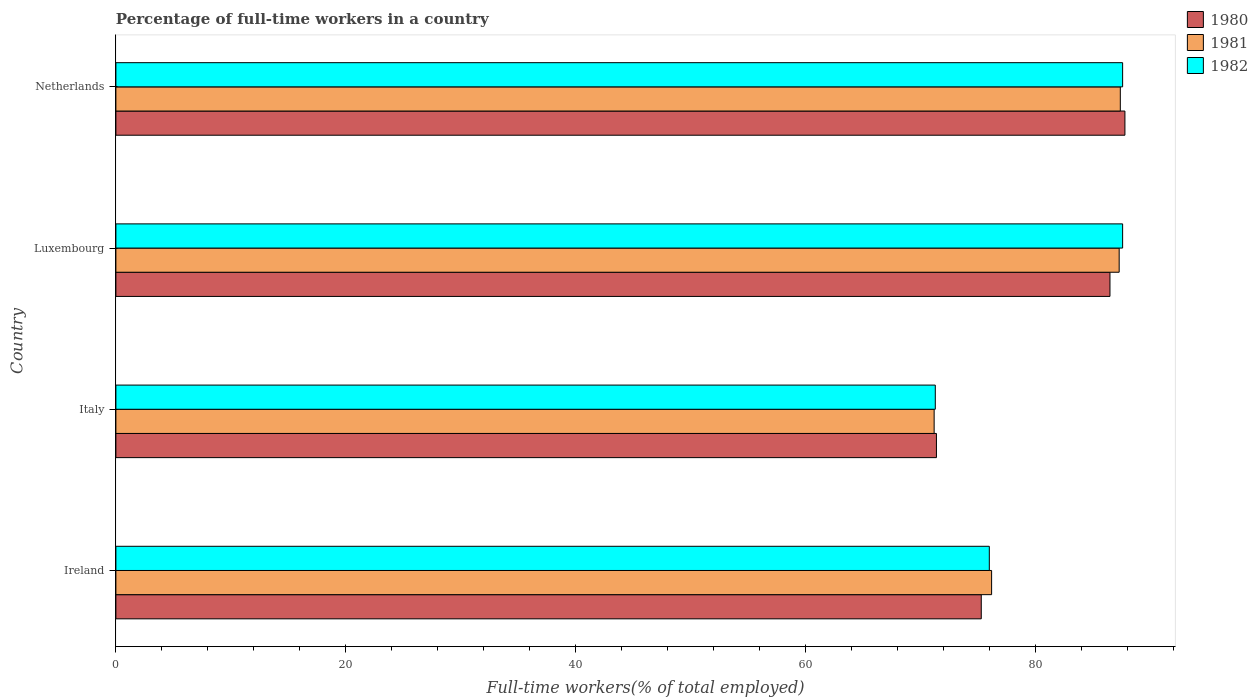How many groups of bars are there?
Provide a short and direct response. 4. Are the number of bars per tick equal to the number of legend labels?
Provide a short and direct response. Yes. What is the label of the 2nd group of bars from the top?
Keep it short and to the point. Luxembourg. What is the percentage of full-time workers in 1980 in Italy?
Give a very brief answer. 71.4. Across all countries, what is the maximum percentage of full-time workers in 1982?
Your answer should be compact. 87.6. Across all countries, what is the minimum percentage of full-time workers in 1981?
Offer a terse response. 71.2. In which country was the percentage of full-time workers in 1982 maximum?
Offer a terse response. Luxembourg. In which country was the percentage of full-time workers in 1981 minimum?
Keep it short and to the point. Italy. What is the total percentage of full-time workers in 1982 in the graph?
Your answer should be very brief. 322.5. What is the difference between the percentage of full-time workers in 1981 in Ireland and that in Luxembourg?
Provide a short and direct response. -11.1. What is the difference between the percentage of full-time workers in 1982 in Italy and the percentage of full-time workers in 1980 in Netherlands?
Keep it short and to the point. -16.5. What is the average percentage of full-time workers in 1981 per country?
Provide a succinct answer. 80.52. What is the difference between the percentage of full-time workers in 1980 and percentage of full-time workers in 1982 in Ireland?
Your answer should be compact. -0.7. In how many countries, is the percentage of full-time workers in 1982 greater than 44 %?
Give a very brief answer. 4. What is the ratio of the percentage of full-time workers in 1981 in Luxembourg to that in Netherlands?
Make the answer very short. 1. Is the difference between the percentage of full-time workers in 1980 in Ireland and Netherlands greater than the difference between the percentage of full-time workers in 1982 in Ireland and Netherlands?
Make the answer very short. No. What is the difference between the highest and the second highest percentage of full-time workers in 1981?
Provide a short and direct response. 0.1. What is the difference between the highest and the lowest percentage of full-time workers in 1981?
Provide a succinct answer. 16.2. In how many countries, is the percentage of full-time workers in 1982 greater than the average percentage of full-time workers in 1982 taken over all countries?
Your response must be concise. 2. Is the sum of the percentage of full-time workers in 1981 in Ireland and Italy greater than the maximum percentage of full-time workers in 1982 across all countries?
Make the answer very short. Yes. What does the 3rd bar from the top in Ireland represents?
Provide a short and direct response. 1980. What does the 3rd bar from the bottom in Luxembourg represents?
Offer a terse response. 1982. How many bars are there?
Your answer should be very brief. 12. Are all the bars in the graph horizontal?
Make the answer very short. Yes. How many countries are there in the graph?
Your answer should be compact. 4. What is the difference between two consecutive major ticks on the X-axis?
Your answer should be very brief. 20. Are the values on the major ticks of X-axis written in scientific E-notation?
Keep it short and to the point. No. Does the graph contain any zero values?
Give a very brief answer. No. What is the title of the graph?
Offer a very short reply. Percentage of full-time workers in a country. What is the label or title of the X-axis?
Make the answer very short. Full-time workers(% of total employed). What is the Full-time workers(% of total employed) in 1980 in Ireland?
Your answer should be compact. 75.3. What is the Full-time workers(% of total employed) in 1981 in Ireland?
Keep it short and to the point. 76.2. What is the Full-time workers(% of total employed) in 1980 in Italy?
Keep it short and to the point. 71.4. What is the Full-time workers(% of total employed) in 1981 in Italy?
Provide a short and direct response. 71.2. What is the Full-time workers(% of total employed) of 1982 in Italy?
Provide a succinct answer. 71.3. What is the Full-time workers(% of total employed) of 1980 in Luxembourg?
Ensure brevity in your answer.  86.5. What is the Full-time workers(% of total employed) in 1981 in Luxembourg?
Your answer should be very brief. 87.3. What is the Full-time workers(% of total employed) in 1982 in Luxembourg?
Make the answer very short. 87.6. What is the Full-time workers(% of total employed) in 1980 in Netherlands?
Provide a short and direct response. 87.8. What is the Full-time workers(% of total employed) of 1981 in Netherlands?
Offer a very short reply. 87.4. What is the Full-time workers(% of total employed) in 1982 in Netherlands?
Make the answer very short. 87.6. Across all countries, what is the maximum Full-time workers(% of total employed) in 1980?
Ensure brevity in your answer.  87.8. Across all countries, what is the maximum Full-time workers(% of total employed) of 1981?
Your response must be concise. 87.4. Across all countries, what is the maximum Full-time workers(% of total employed) of 1982?
Ensure brevity in your answer.  87.6. Across all countries, what is the minimum Full-time workers(% of total employed) in 1980?
Your answer should be compact. 71.4. Across all countries, what is the minimum Full-time workers(% of total employed) of 1981?
Give a very brief answer. 71.2. Across all countries, what is the minimum Full-time workers(% of total employed) of 1982?
Your response must be concise. 71.3. What is the total Full-time workers(% of total employed) of 1980 in the graph?
Make the answer very short. 321. What is the total Full-time workers(% of total employed) of 1981 in the graph?
Offer a terse response. 322.1. What is the total Full-time workers(% of total employed) in 1982 in the graph?
Give a very brief answer. 322.5. What is the difference between the Full-time workers(% of total employed) in 1982 in Ireland and that in Italy?
Your response must be concise. 4.7. What is the difference between the Full-time workers(% of total employed) in 1980 in Ireland and that in Luxembourg?
Provide a succinct answer. -11.2. What is the difference between the Full-time workers(% of total employed) of 1981 in Ireland and that in Luxembourg?
Provide a succinct answer. -11.1. What is the difference between the Full-time workers(% of total employed) in 1980 in Ireland and that in Netherlands?
Offer a very short reply. -12.5. What is the difference between the Full-time workers(% of total employed) in 1981 in Ireland and that in Netherlands?
Provide a short and direct response. -11.2. What is the difference between the Full-time workers(% of total employed) of 1982 in Ireland and that in Netherlands?
Ensure brevity in your answer.  -11.6. What is the difference between the Full-time workers(% of total employed) of 1980 in Italy and that in Luxembourg?
Offer a terse response. -15.1. What is the difference between the Full-time workers(% of total employed) of 1981 in Italy and that in Luxembourg?
Provide a short and direct response. -16.1. What is the difference between the Full-time workers(% of total employed) in 1982 in Italy and that in Luxembourg?
Keep it short and to the point. -16.3. What is the difference between the Full-time workers(% of total employed) of 1980 in Italy and that in Netherlands?
Your response must be concise. -16.4. What is the difference between the Full-time workers(% of total employed) of 1981 in Italy and that in Netherlands?
Keep it short and to the point. -16.2. What is the difference between the Full-time workers(% of total employed) of 1982 in Italy and that in Netherlands?
Your response must be concise. -16.3. What is the difference between the Full-time workers(% of total employed) in 1980 in Luxembourg and that in Netherlands?
Give a very brief answer. -1.3. What is the difference between the Full-time workers(% of total employed) of 1982 in Luxembourg and that in Netherlands?
Your response must be concise. 0. What is the difference between the Full-time workers(% of total employed) of 1980 in Ireland and the Full-time workers(% of total employed) of 1982 in Italy?
Offer a very short reply. 4. What is the difference between the Full-time workers(% of total employed) in 1981 in Ireland and the Full-time workers(% of total employed) in 1982 in Italy?
Your answer should be very brief. 4.9. What is the difference between the Full-time workers(% of total employed) of 1980 in Ireland and the Full-time workers(% of total employed) of 1981 in Netherlands?
Provide a short and direct response. -12.1. What is the difference between the Full-time workers(% of total employed) of 1980 in Ireland and the Full-time workers(% of total employed) of 1982 in Netherlands?
Your answer should be compact. -12.3. What is the difference between the Full-time workers(% of total employed) in 1980 in Italy and the Full-time workers(% of total employed) in 1981 in Luxembourg?
Offer a very short reply. -15.9. What is the difference between the Full-time workers(% of total employed) in 1980 in Italy and the Full-time workers(% of total employed) in 1982 in Luxembourg?
Your answer should be very brief. -16.2. What is the difference between the Full-time workers(% of total employed) in 1981 in Italy and the Full-time workers(% of total employed) in 1982 in Luxembourg?
Offer a terse response. -16.4. What is the difference between the Full-time workers(% of total employed) in 1980 in Italy and the Full-time workers(% of total employed) in 1982 in Netherlands?
Give a very brief answer. -16.2. What is the difference between the Full-time workers(% of total employed) in 1981 in Italy and the Full-time workers(% of total employed) in 1982 in Netherlands?
Make the answer very short. -16.4. What is the difference between the Full-time workers(% of total employed) in 1980 in Luxembourg and the Full-time workers(% of total employed) in 1981 in Netherlands?
Offer a very short reply. -0.9. What is the difference between the Full-time workers(% of total employed) in 1980 in Luxembourg and the Full-time workers(% of total employed) in 1982 in Netherlands?
Provide a short and direct response. -1.1. What is the average Full-time workers(% of total employed) in 1980 per country?
Offer a terse response. 80.25. What is the average Full-time workers(% of total employed) in 1981 per country?
Offer a terse response. 80.53. What is the average Full-time workers(% of total employed) of 1982 per country?
Make the answer very short. 80.62. What is the difference between the Full-time workers(% of total employed) in 1981 and Full-time workers(% of total employed) in 1982 in Ireland?
Offer a very short reply. 0.2. What is the difference between the Full-time workers(% of total employed) in 1980 and Full-time workers(% of total employed) in 1982 in Italy?
Make the answer very short. 0.1. What is the difference between the Full-time workers(% of total employed) in 1980 and Full-time workers(% of total employed) in 1981 in Luxembourg?
Ensure brevity in your answer.  -0.8. What is the difference between the Full-time workers(% of total employed) of 1980 and Full-time workers(% of total employed) of 1982 in Luxembourg?
Make the answer very short. -1.1. What is the difference between the Full-time workers(% of total employed) in 1981 and Full-time workers(% of total employed) in 1982 in Luxembourg?
Keep it short and to the point. -0.3. What is the ratio of the Full-time workers(% of total employed) in 1980 in Ireland to that in Italy?
Keep it short and to the point. 1.05. What is the ratio of the Full-time workers(% of total employed) in 1981 in Ireland to that in Italy?
Give a very brief answer. 1.07. What is the ratio of the Full-time workers(% of total employed) in 1982 in Ireland to that in Italy?
Your answer should be compact. 1.07. What is the ratio of the Full-time workers(% of total employed) in 1980 in Ireland to that in Luxembourg?
Offer a very short reply. 0.87. What is the ratio of the Full-time workers(% of total employed) in 1981 in Ireland to that in Luxembourg?
Offer a terse response. 0.87. What is the ratio of the Full-time workers(% of total employed) in 1982 in Ireland to that in Luxembourg?
Your answer should be compact. 0.87. What is the ratio of the Full-time workers(% of total employed) in 1980 in Ireland to that in Netherlands?
Offer a very short reply. 0.86. What is the ratio of the Full-time workers(% of total employed) of 1981 in Ireland to that in Netherlands?
Keep it short and to the point. 0.87. What is the ratio of the Full-time workers(% of total employed) in 1982 in Ireland to that in Netherlands?
Offer a very short reply. 0.87. What is the ratio of the Full-time workers(% of total employed) of 1980 in Italy to that in Luxembourg?
Give a very brief answer. 0.83. What is the ratio of the Full-time workers(% of total employed) in 1981 in Italy to that in Luxembourg?
Provide a succinct answer. 0.82. What is the ratio of the Full-time workers(% of total employed) in 1982 in Italy to that in Luxembourg?
Offer a very short reply. 0.81. What is the ratio of the Full-time workers(% of total employed) of 1980 in Italy to that in Netherlands?
Provide a succinct answer. 0.81. What is the ratio of the Full-time workers(% of total employed) in 1981 in Italy to that in Netherlands?
Make the answer very short. 0.81. What is the ratio of the Full-time workers(% of total employed) of 1982 in Italy to that in Netherlands?
Provide a short and direct response. 0.81. What is the ratio of the Full-time workers(% of total employed) in 1980 in Luxembourg to that in Netherlands?
Your response must be concise. 0.99. What is the ratio of the Full-time workers(% of total employed) of 1981 in Luxembourg to that in Netherlands?
Your response must be concise. 1. What is the difference between the highest and the second highest Full-time workers(% of total employed) of 1981?
Give a very brief answer. 0.1. What is the difference between the highest and the lowest Full-time workers(% of total employed) in 1980?
Provide a short and direct response. 16.4. What is the difference between the highest and the lowest Full-time workers(% of total employed) in 1982?
Provide a short and direct response. 16.3. 